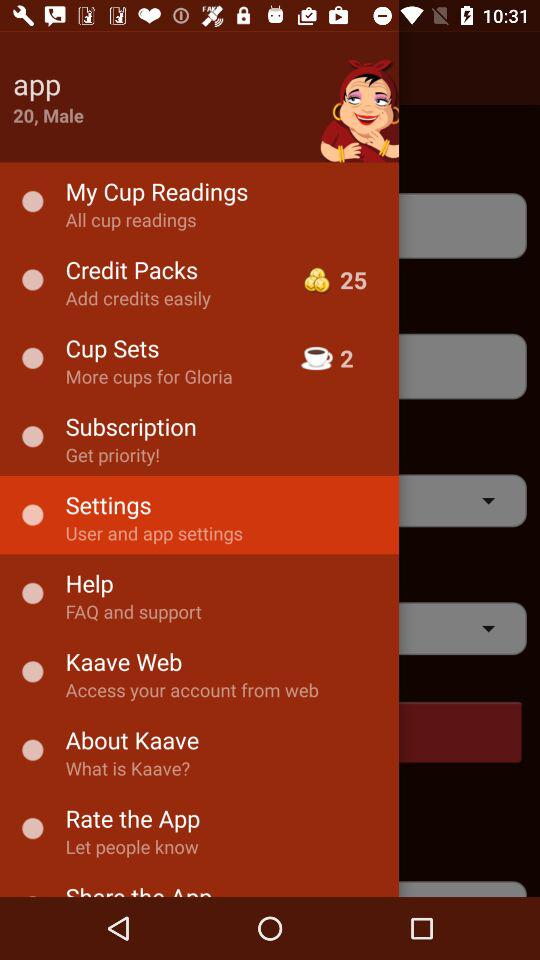What is the username? The username is "app". 